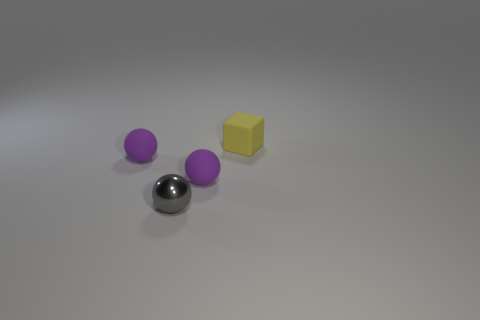Subtract all red cubes. Subtract all green spheres. How many cubes are left? 1 Subtract all cyan blocks. How many yellow spheres are left? 0 Add 2 small grays. How many tiny objects exist? 0 Subtract all tiny metal spheres. Subtract all blocks. How many objects are left? 2 Add 4 gray shiny spheres. How many gray shiny spheres are left? 5 Add 1 tiny purple matte spheres. How many tiny purple matte spheres exist? 3 Add 1 purple balls. How many objects exist? 5 Subtract all gray balls. How many balls are left? 2 Subtract all tiny matte balls. How many balls are left? 1 Subtract 0 blue blocks. How many objects are left? 4 